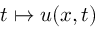Convert formula to latex. <formula><loc_0><loc_0><loc_500><loc_500>t \mapsto u ( x , t )</formula> 